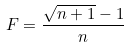<formula> <loc_0><loc_0><loc_500><loc_500>F = \frac { \sqrt { n + 1 } - 1 } { n }</formula> 